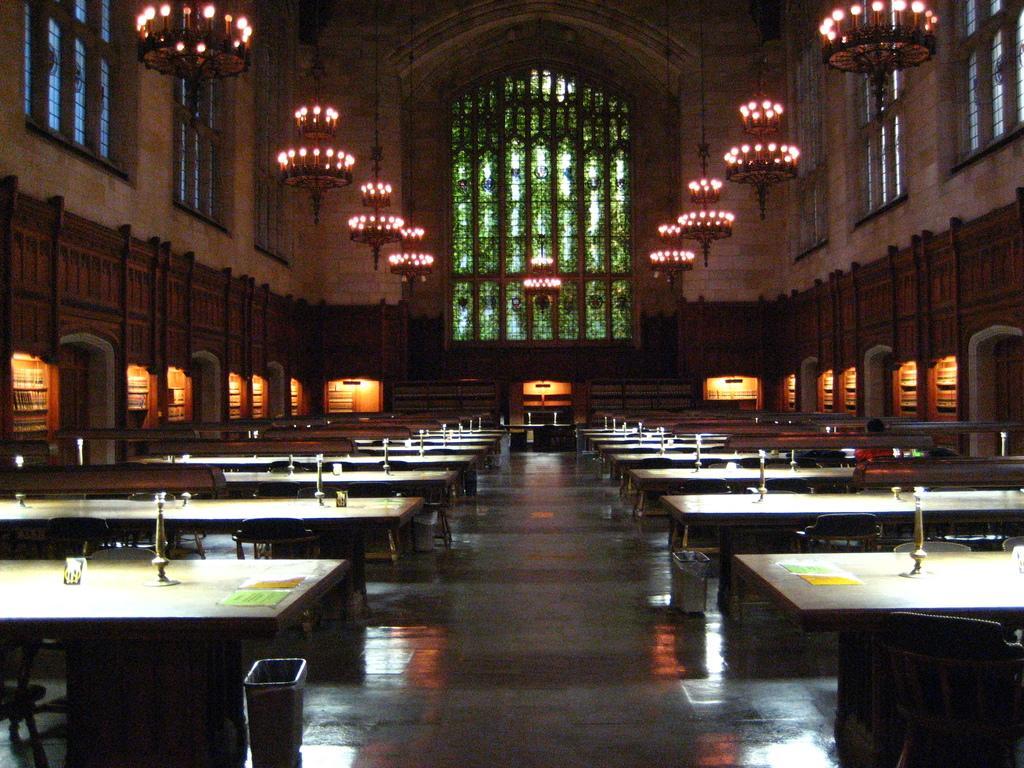Describe this image in one or two sentences. In the image in the center we can see tables,vouchers,dustbins and few other objects. In the background there is a wall,windows,lights etc. 